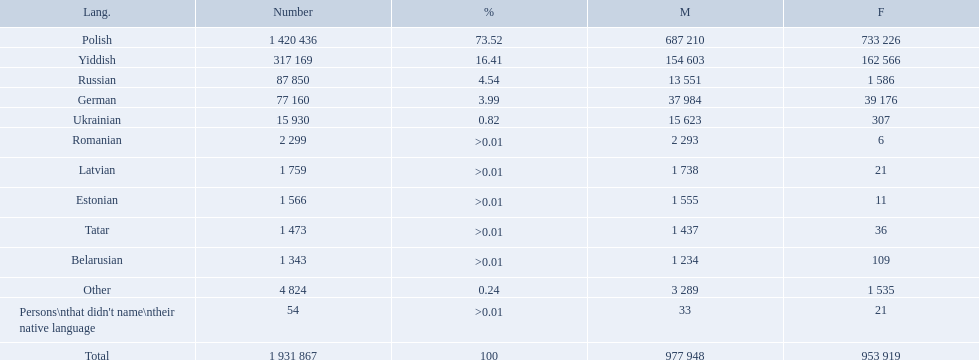What named native languages spoken in the warsaw governorate have more males then females? Russian, Ukrainian, Romanian, Latvian, Estonian, Tatar, Belarusian. Which of those have less then 500 males listed? Romanian, Latvian, Estonian, Tatar, Belarusian. Of the remaining languages which of them have less then 20 females? Romanian, Estonian. Which of these has the highest total number listed? Romanian. What are all of the languages used in the warsaw governorate? Polish, Yiddish, Russian, German, Ukrainian, Romanian, Latvian, Estonian, Tatar, Belarusian, Other, Persons\nthat didn't name\ntheir native language. Which language was comprised of the least number of female speakers? Romanian. What are all the languages? Polish, Yiddish, Russian, German, Ukrainian, Romanian, Latvian, Estonian, Tatar, Belarusian, Other, Persons\nthat didn't name\ntheir native language. Of those languages, which five had fewer than 50 females speaking it? 6, 21, 11, 36, 21. Of those five languages, which is the lowest? Romanian. What is the percentage of polish speakers? 73.52. What is the next highest percentage of speakers? 16.41. What language is this percentage? Yiddish. What languages are spoken in the warsaw governorate? Polish, Yiddish, Russian, German, Ukrainian, Romanian, Latvian, Estonian, Tatar, Belarusian. Which are the top five languages? Polish, Yiddish, Russian, German, Ukrainian. Of those which is the 2nd most frequently spoken? Yiddish. What are all the spoken languages? Polish, Yiddish, Russian, German, Ukrainian, Romanian, Latvian, Estonian, Tatar, Belarusian. Which one of these has the most people speaking it? Polish. Which languages had percentages of >0.01? Romanian, Latvian, Estonian, Tatar, Belarusian. What was the top language? Romanian. 